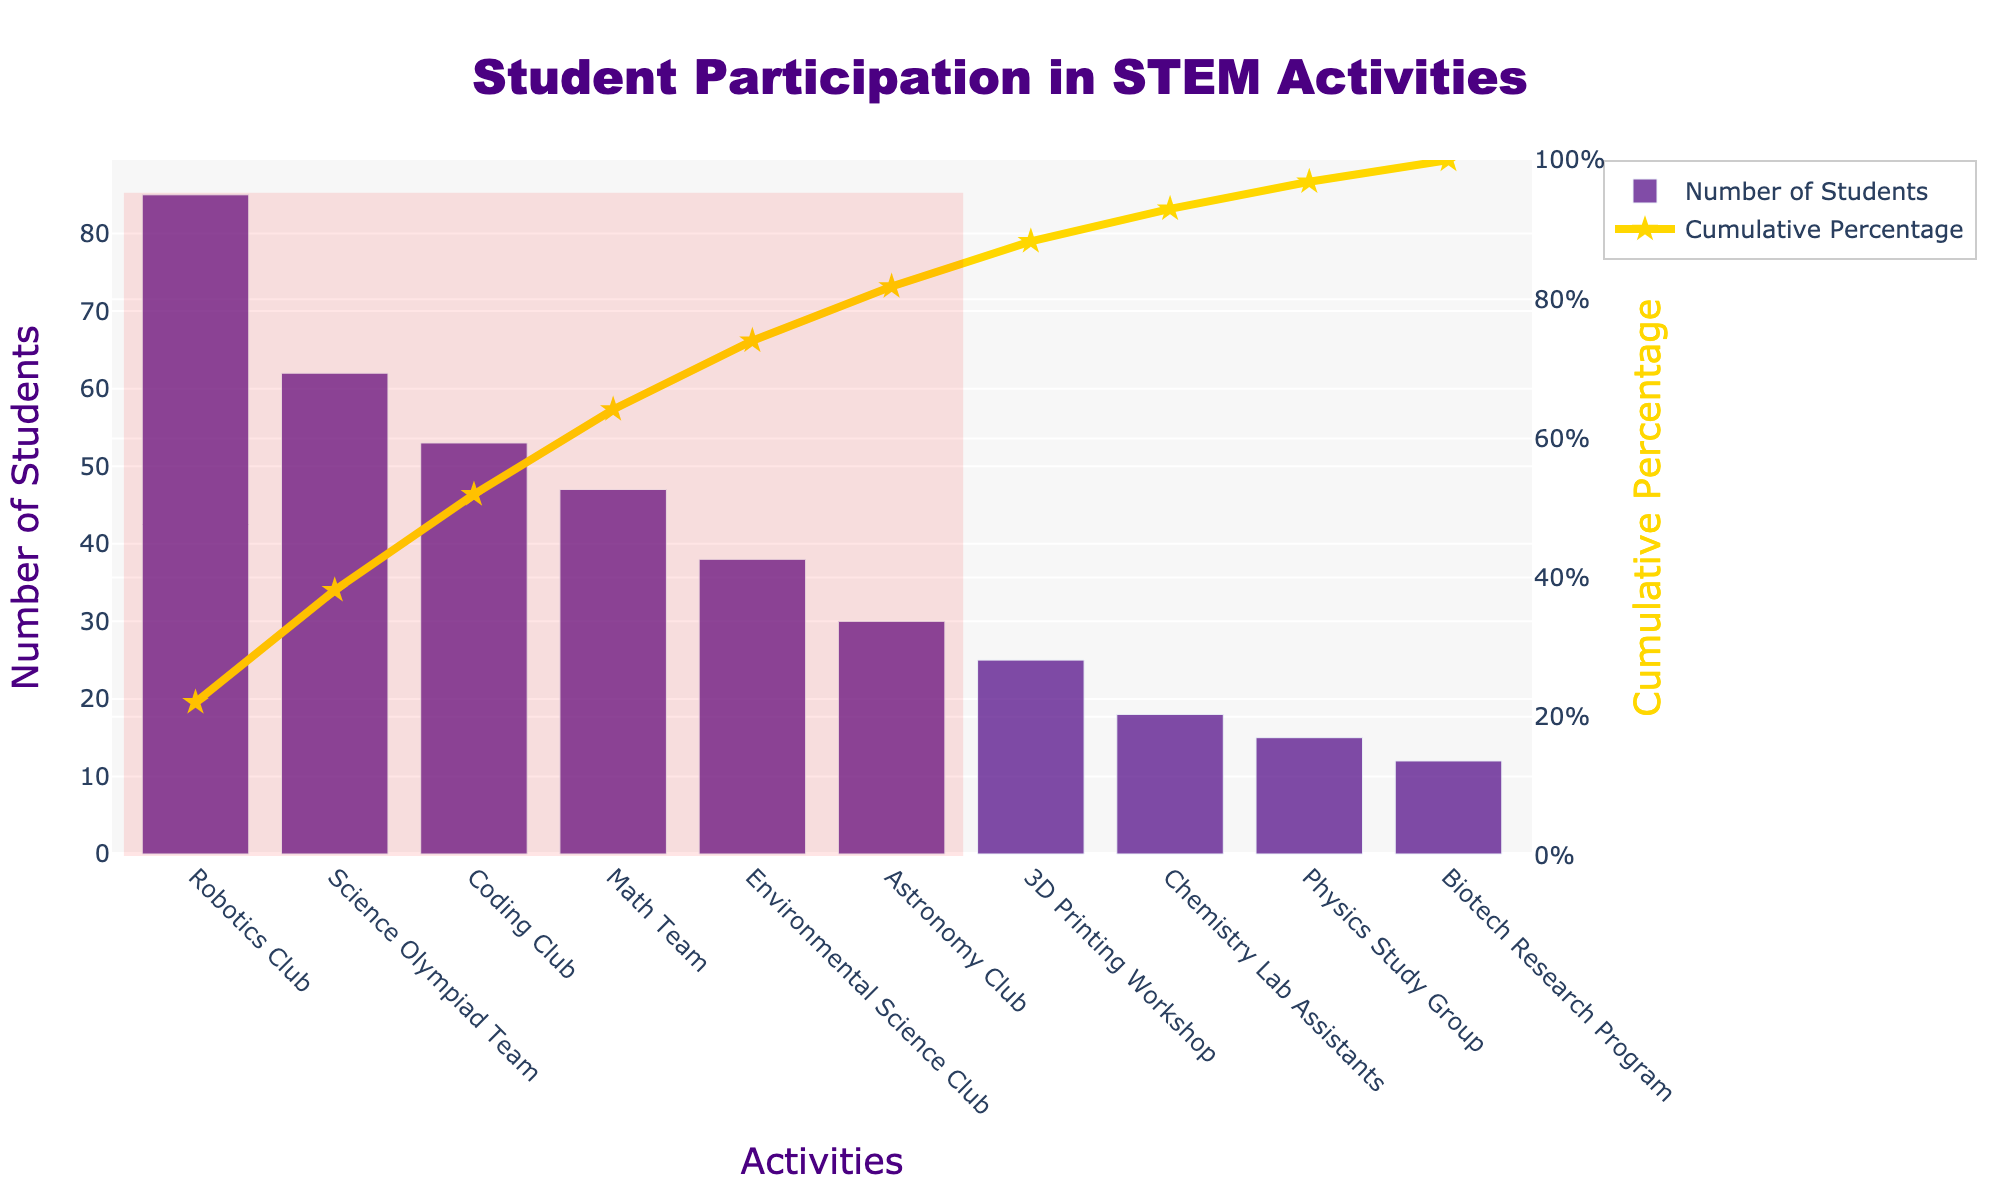How many students participate in the Robotics Club? The number of students participating in the Robotics Club is represented by the height of the first bar in the bar chart. Since the chart is sorted by the number of students, the first bar, representing Robotics Club, shows 85 students.
Answer: 85 What is the cumulative percentage of students participating in the top two activities? The cumulative percentage can be seen from the line chart. The cumulative percentage after the second activity, Science Olympiad Team, reaches approximately 69.2% (from the cumulative percentage points corresponding to Robotics Club and Science Olympiad Team).
Answer: 69.2% What activity has the lowest number of participating students? The lowest bar on the chart represents the activity with the lowest number of students, which is the Biotech Research Program with 12 students.
Answer: Biotech Research Program Which activity sees a participation of less than 20 students? Examining the bars, the activities where the bar's height falls below the 20-student mark are Chemistry Lab Assistants and Physics Study Group.
Answer: Chemistry Lab Assistants and Physics Study Group Which activities are included in the highlighted section representing the cumulative 80% threshold? The highlighted section of the chart encompasses the activities that cumulatively account for 80% of the participating students. This includes Robotics Club, Science Olympiad Team, Coding Club, Math Team, and Environmental Science Club.
Answer: Robotics Club, Science Olympiad Team, Coding Club, Math Team, Environmental Science Club How many more students participate in the Coding Club compared to the Astronomy Club? The number of students in the Coding Club is 53 and in the Astronomy Club is 30. Subtracting the Astronomy Club from the Coding Club gives: 53 - 30 = 23.
Answer: 23 What percentage of the total student participation does the Environmental Science Club represent? The Environmental Science Club has 38 students. To find the percentage, divide 38 by the total number of students (total from all activities) and multiply by 100. Total = 385. Percentage = (38/385) * 100 ≈ 9.87%.
Answer: 9.87% What is the cumulative percentage after three activities? Adding the cumulative percentages for the first three activities: Robotics Club (approximately 22.1%), Science Olympiad Team (47.3%), and Coding Club (61.0%), the cumulative percentage after the third activity is around 61.0%.
Answer: 61.0% What is the total number of students participating in the top five activities? Adding the number of students in the top five activities: Robotics Club (85), Science Olympiad Team (62), Coding Club (53), Math Team (47), and Environmental Science Club (38) gives a total of 285 students.
Answer: 285 How does participation in the Math Team compare to the Physics Study Group? The Math Team has 47 students while the Physics Study Group has 15 students. To compare, we note that the Math Team has significantly higher participation.
Answer: The Math Team has 32 more students than the Physics Study Group 